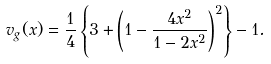Convert formula to latex. <formula><loc_0><loc_0><loc_500><loc_500>v _ { g } ( x ) = \frac { 1 } { 4 } \left \{ 3 + \left ( 1 - \frac { 4 x ^ { 2 } } { 1 - 2 x ^ { 2 } } \right ) ^ { 2 } \right \} - 1 .</formula> 